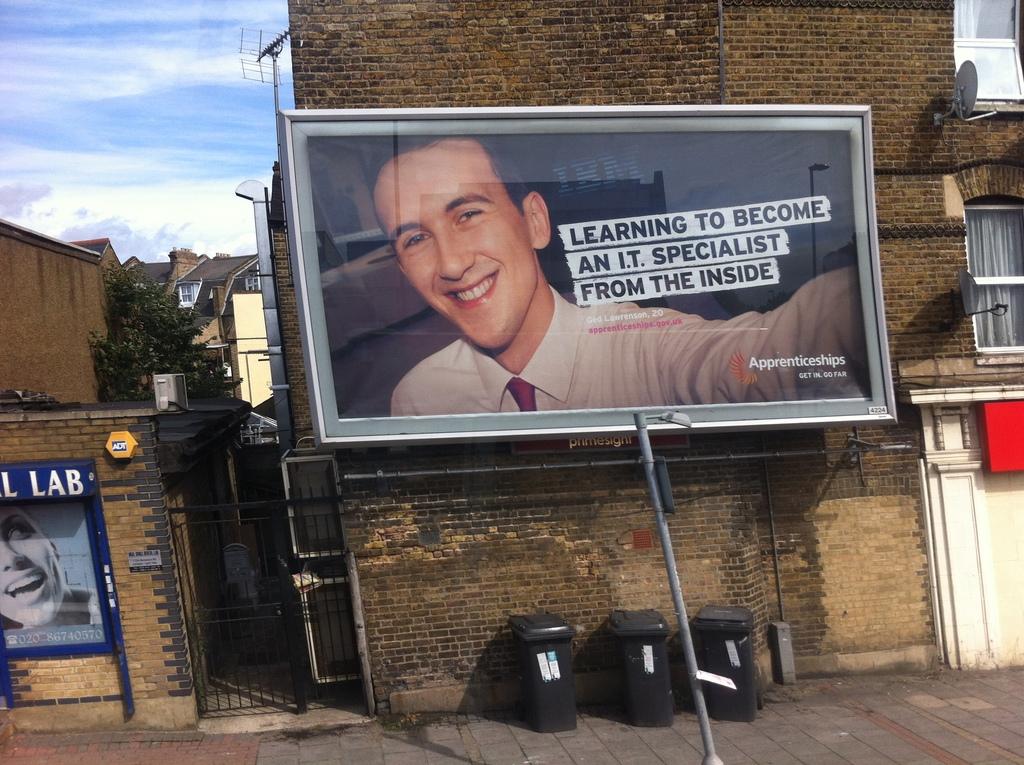What is the gender of the person on the billboard?
Make the answer very short. Answering does not require reading text in the image. 